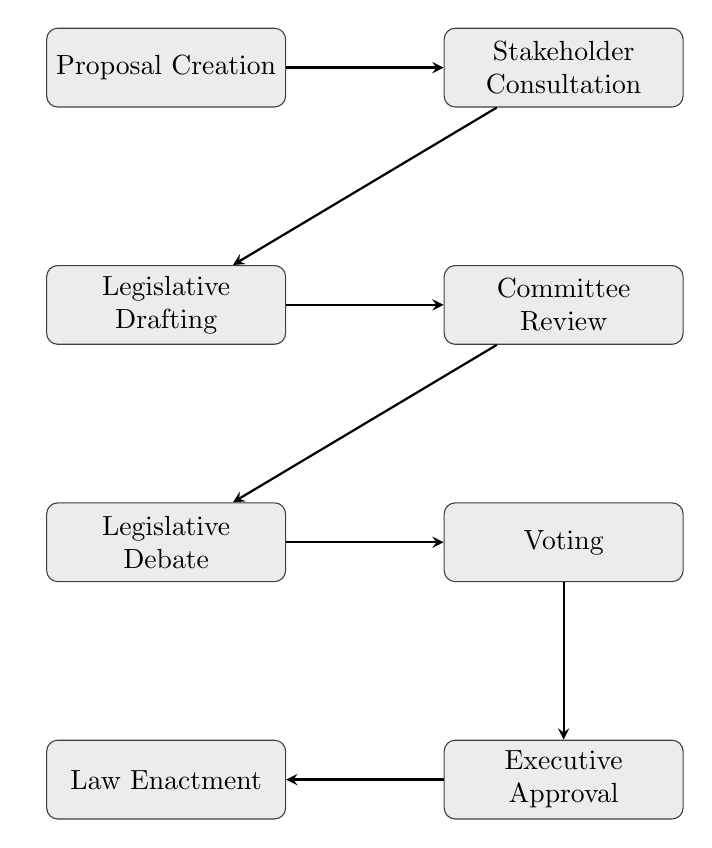What is the first step in the electoral reform process? The first step indicated in the flow chart is "Proposal Creation," where a draft of the electoral reform proposal is created.
Answer: Proposal Creation How many total steps are involved in the diagram? The diagram contains a series of eight distinct steps, each representing a part of the electoral reform process.
Answer: Eight Which step immediately follows "Stakeholder Consultation"? According to the diagram, the step that immediately follows "Stakeholder Consultation" is "Legislative Drafting."
Answer: Legislative Drafting What is the last step in the process? The final step illustrated in the flow chart is "Law Enactment," where the reform is enacted into law.
Answer: Law Enactment What action follows after "Executive Approval"? Following "Executive Approval," the next action shown in the diagram is "Law Enactment."
Answer: Law Enactment What two steps are evaluated during the legislative phase? The two steps evaluated during the legislative phase are "Legislative Debate" and "Voting," which are essential for discussing and deciding on the proposed bill.
Answer: Legislative Debate and Voting In what sequence do "Legislative Drafting" and "Committee Review" occur? "Legislative Drafting" occurs before "Committee Review" in the sequence of the diagram. This means a draft must be created before it can be reviewed by committees.
Answer: Legislative Drafting then Committee Review What is required for the proposed bill to move past the "Voting" step? To move past the "Voting" step, the proposed bill must achieve a majority vote in the legislative body, as indicated in the flowchart.
Answer: Majority vote Which two processes directly lead to "Law Enactment"? The processes that directly lead to "Law Enactment" are "Executive Approval" and the preceding legislative steps, which highlight the approval from leadership before enacting the law.
Answer: Executive Approval and legislative steps 